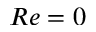<formula> <loc_0><loc_0><loc_500><loc_500>R e = 0</formula> 